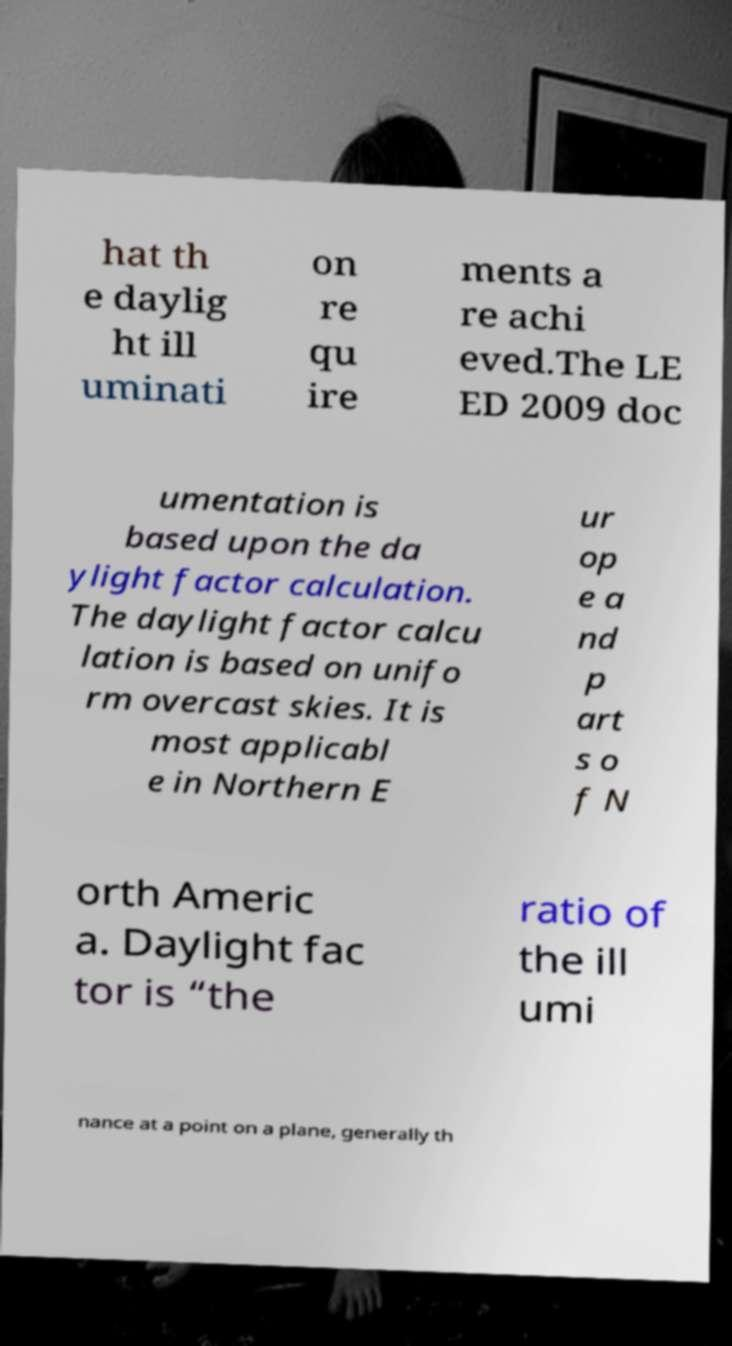What messages or text are displayed in this image? I need them in a readable, typed format. hat th e daylig ht ill uminati on re qu ire ments a re achi eved.The LE ED 2009 doc umentation is based upon the da ylight factor calculation. The daylight factor calcu lation is based on unifo rm overcast skies. It is most applicabl e in Northern E ur op e a nd p art s o f N orth Americ a. Daylight fac tor is “the ratio of the ill umi nance at a point on a plane, generally th 